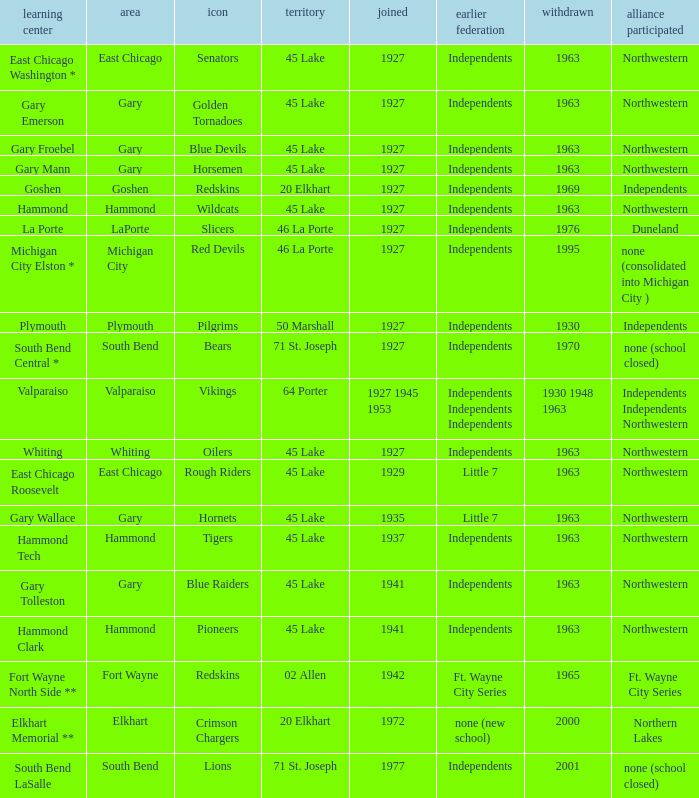Which conference held at School of whiting? Independents. 